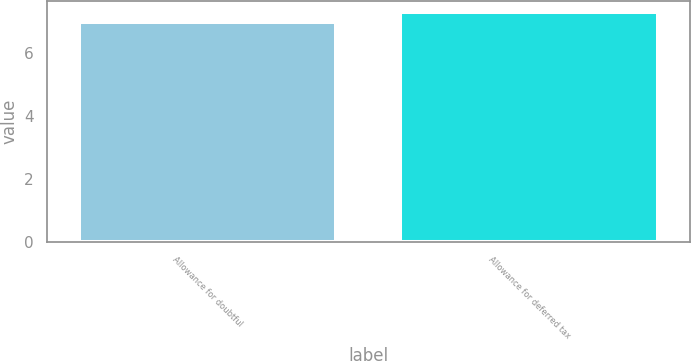<chart> <loc_0><loc_0><loc_500><loc_500><bar_chart><fcel>Allowance for doubtful<fcel>Allowance for deferred tax<nl><fcel>7<fcel>7.3<nl></chart> 